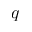Convert formula to latex. <formula><loc_0><loc_0><loc_500><loc_500>q</formula> 